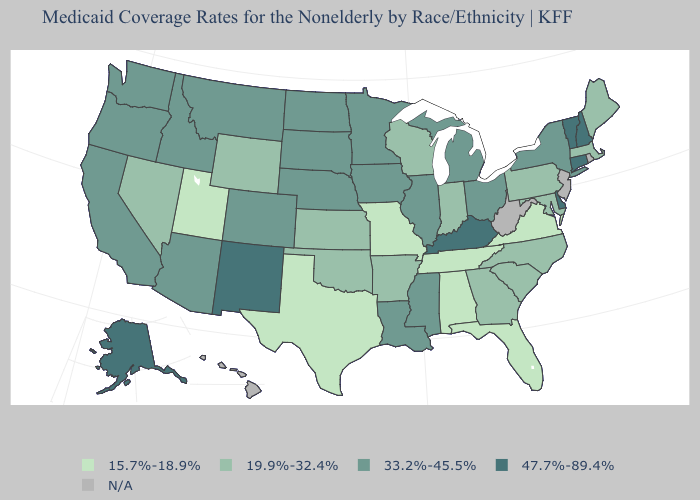Which states have the lowest value in the Northeast?
Give a very brief answer. Maine, Massachusetts, Pennsylvania. Name the states that have a value in the range 15.7%-18.9%?
Answer briefly. Alabama, Florida, Missouri, Tennessee, Texas, Utah, Virginia. Does South Dakota have the highest value in the MidWest?
Answer briefly. Yes. Does Nebraska have the highest value in the MidWest?
Short answer required. Yes. Which states have the lowest value in the MidWest?
Keep it brief. Missouri. What is the lowest value in the West?
Answer briefly. 15.7%-18.9%. What is the value of North Carolina?
Keep it brief. 19.9%-32.4%. How many symbols are there in the legend?
Write a very short answer. 5. What is the value of North Dakota?
Write a very short answer. 33.2%-45.5%. Does Massachusetts have the lowest value in the Northeast?
Concise answer only. Yes. Does Vermont have the highest value in the Northeast?
Write a very short answer. Yes. Name the states that have a value in the range N/A?
Be succinct. Hawaii, New Jersey, Rhode Island, West Virginia. Does Connecticut have the highest value in the USA?
Give a very brief answer. Yes. What is the value of Vermont?
Be succinct. 47.7%-89.4%. What is the value of Washington?
Answer briefly. 33.2%-45.5%. 